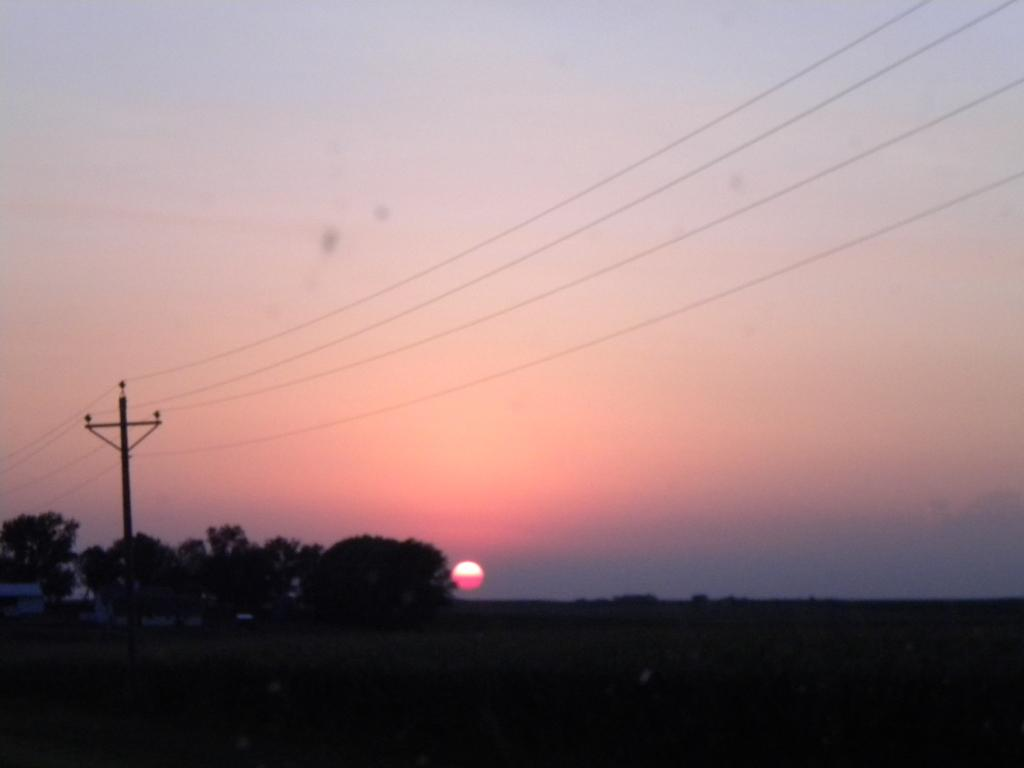What is located far away in the image? There is a surface far away in the image. What type of vegetation can be seen in the image? There are trees visible in the image. What is attached to the pole in the image? The pole has wires attached to it. What is visible in the background of the image? The sky is visible in the background of the image. Can the sun be seen in the image? Yes, the sun is observable in the sky. What type of prison can be seen in the image? There is no prison present in the image. What scientific theory is being demonstrated in the image? There is no scientific theory being demonstrated in the image. 